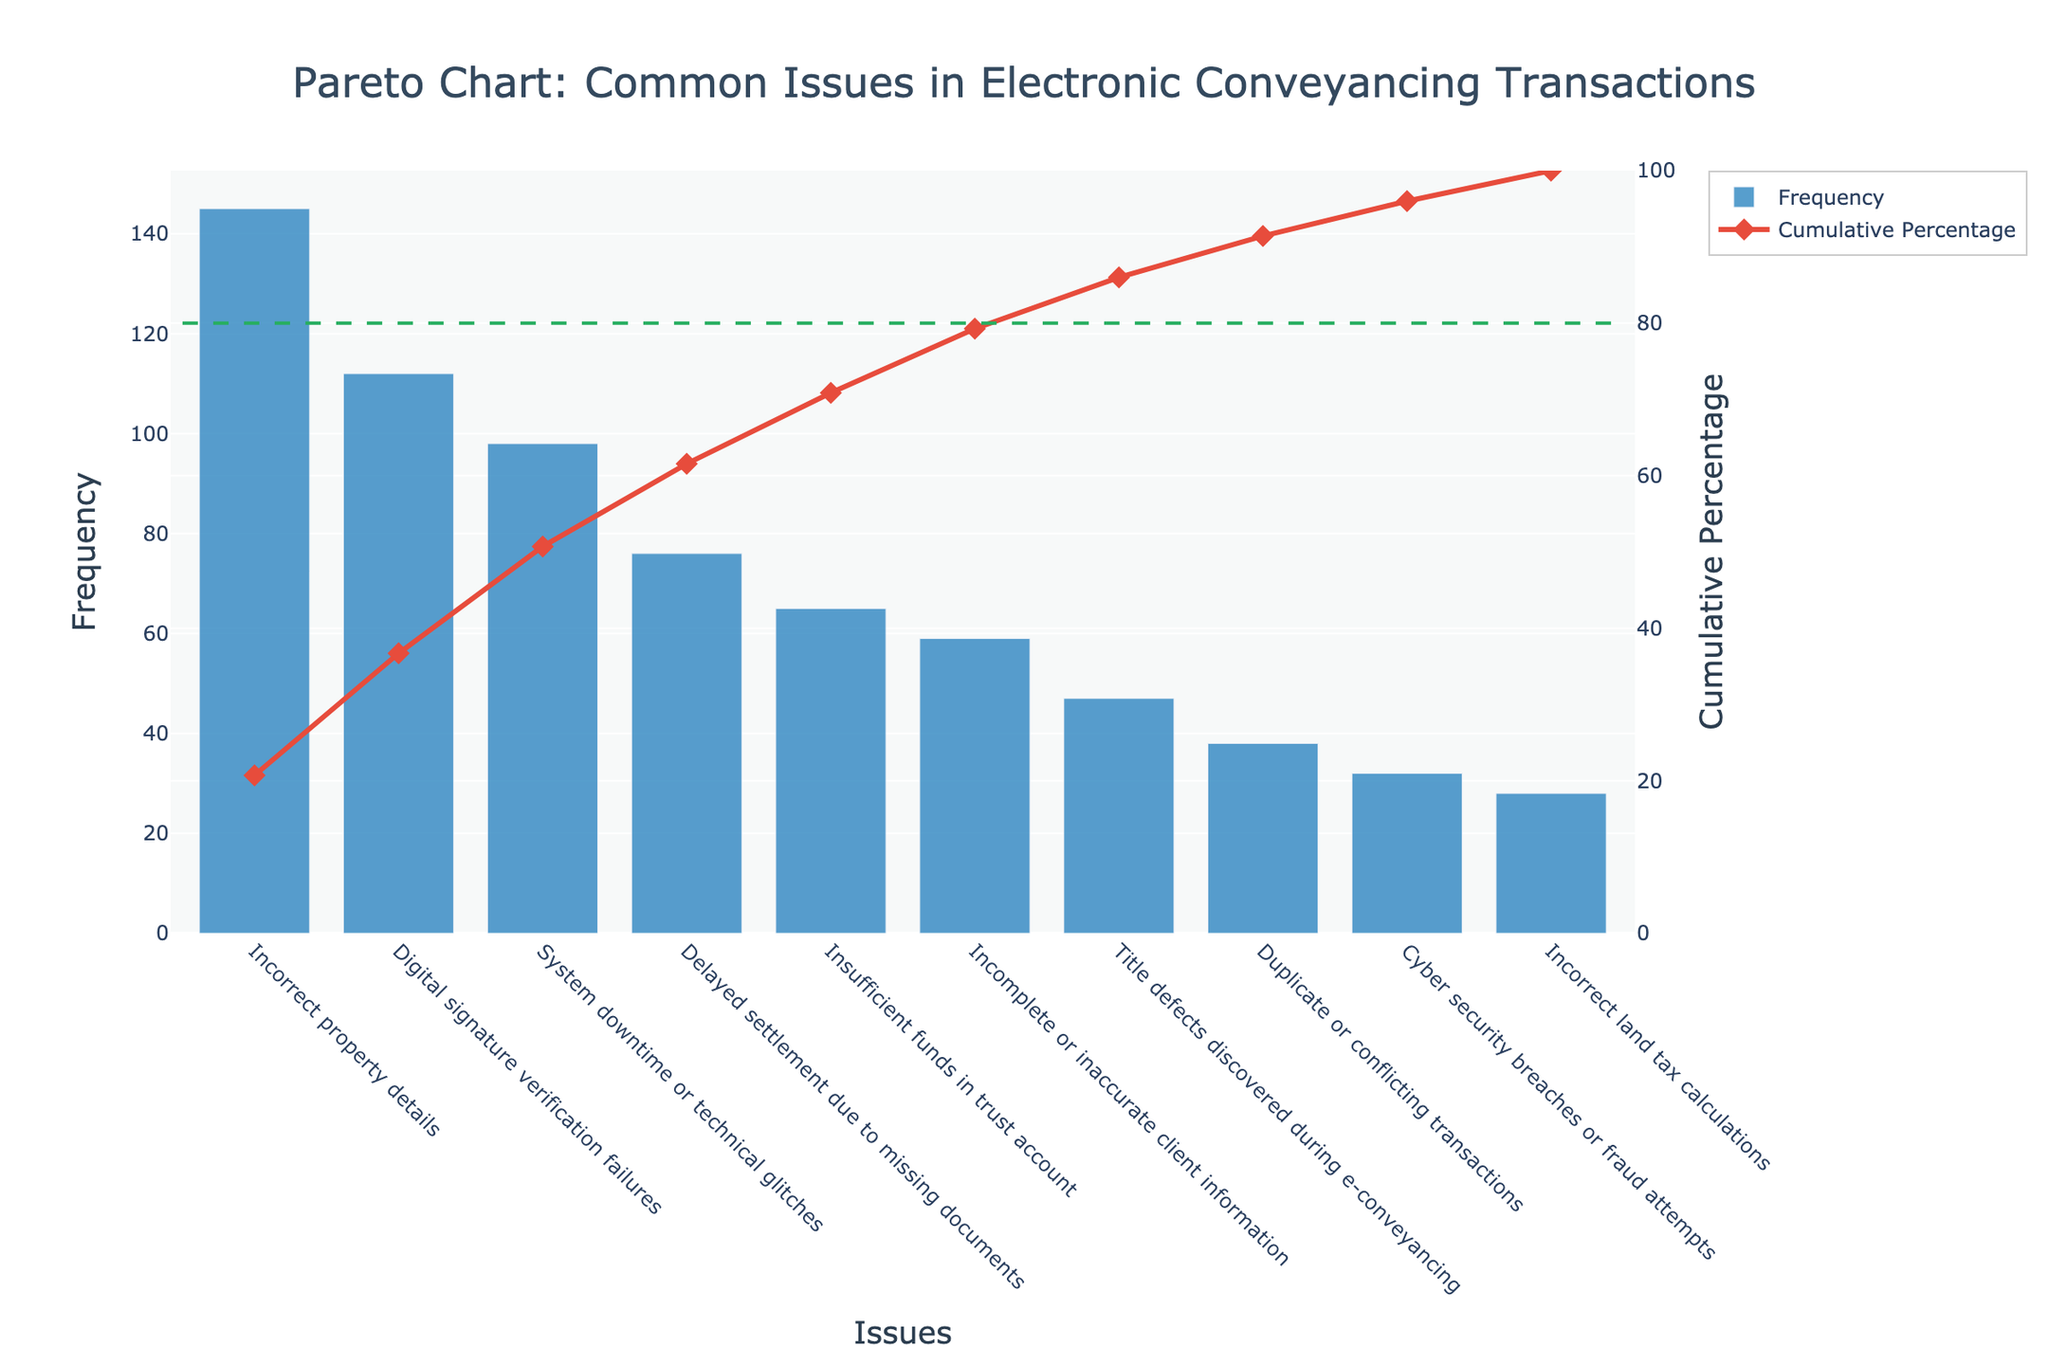What is the most common issue in electronic conveyancing transactions according to the Pareto chart? The most common issue can be identified by observing the category with the highest bar in the chart. The tallest bar represents 'Incorrect property details' with a frequency of 145.
Answer: Incorrect property details Which issue has the lowest frequency? By examining the shortest bar in the chart, we can see that 'Incorrect land tax calculations' has the lowest frequency, which is 28.
Answer: Incorrect land tax calculations What is the cumulative percentage up to 'System downtime or technical glitches'? Look at the cumulative percentage line at 'System downtime or technical glitches'. The cumulative percentage for this issue is 73.02%.
Answer: 73.02% How many issues account for approximately 80% of the total frequency? We need to identify the point where the cumulative percentage line crosses 80%. In this case, 80% refers to the cumulative total of the first 4 issues: 'Incorrect property details', 'Digital signature verification failures', 'System downtime or technical glitches', and 'Delayed settlement due to missing documents'.
Answer: 4 issues What is the total frequency of all the issues combined? Add the frequencies of all the issues listed. 145 + 112 + 98 + 76 + 65 + 59 + 47 + 38 + 32 + 28 = 700.
Answer: 700 By how much does the frequency of 'Incorrect property details' exceed 'Cyber security breaches or fraud attempts'? To find the difference, subtract the frequency of 'Cyber security breaches or fraud attempts' (32) from 'Incorrect property details' (145). 145 - 32 = 113.
Answer: 113 What is the average frequency of the issues? Calculate the average by dividing the total frequency by the number of issues. The total frequency is 700, and there are 10 issues. 700 / 10 = 70.
Answer: 70 Which issue ranks third place based on frequency? The third tallest bar in the chart corresponds to 'System downtime or technical glitches' with a frequency of 98.
Answer: System downtime or technical glitches What is the cumulative percentage at 'Title defects discovered during e-conveyancing'? Look at the cumulative percentage line at 'Title defects discovered during e-conveyancing'. The cumulative percentage for this issue is 86.4%.
Answer: 86.4% What is the combined frequency of issues ranked 5th and 6th? The issues ranked 5th and 6th are 'Insufficient funds in trust account' (65) and 'Incomplete or inaccurate client information' (59). Their combined frequency is 65 + 59 = 124.
Answer: 124 